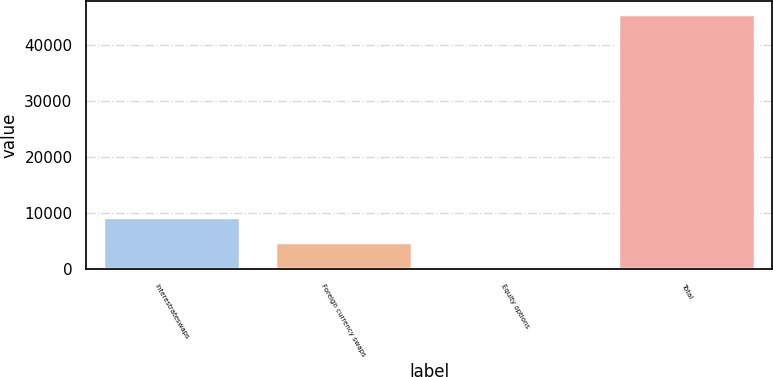Convert chart. <chart><loc_0><loc_0><loc_500><loc_500><bar_chart><fcel>Interestrateswaps<fcel>Foreign currency swaps<fcel>Equity options<fcel>Total<nl><fcel>9385.6<fcel>4870.3<fcel>355<fcel>45508<nl></chart> 